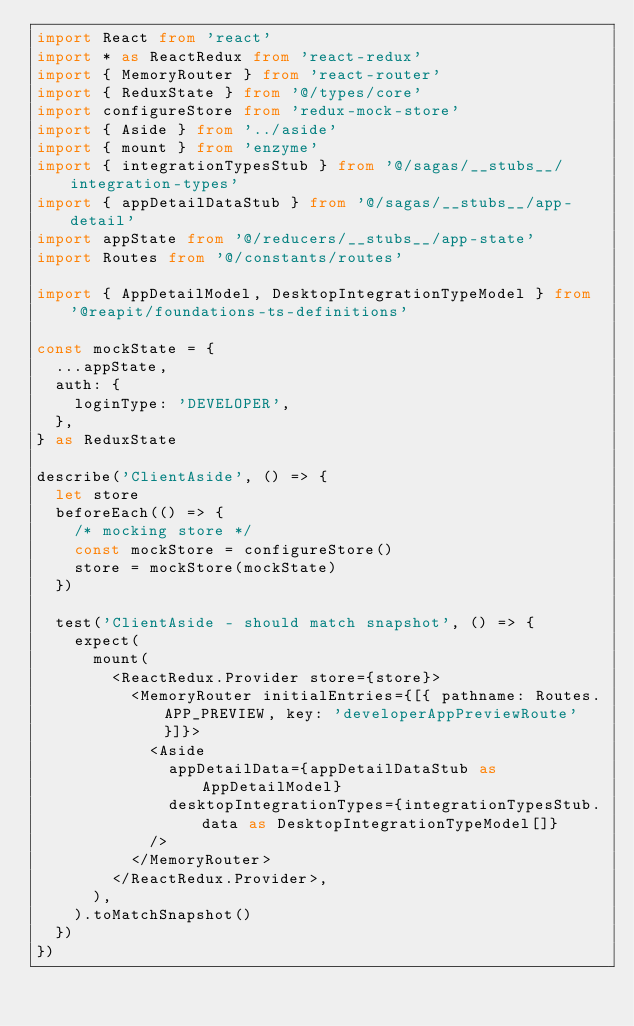<code> <loc_0><loc_0><loc_500><loc_500><_TypeScript_>import React from 'react'
import * as ReactRedux from 'react-redux'
import { MemoryRouter } from 'react-router'
import { ReduxState } from '@/types/core'
import configureStore from 'redux-mock-store'
import { Aside } from '../aside'
import { mount } from 'enzyme'
import { integrationTypesStub } from '@/sagas/__stubs__/integration-types'
import { appDetailDataStub } from '@/sagas/__stubs__/app-detail'
import appState from '@/reducers/__stubs__/app-state'
import Routes from '@/constants/routes'

import { AppDetailModel, DesktopIntegrationTypeModel } from '@reapit/foundations-ts-definitions'

const mockState = {
  ...appState,
  auth: {
    loginType: 'DEVELOPER',
  },
} as ReduxState

describe('ClientAside', () => {
  let store
  beforeEach(() => {
    /* mocking store */
    const mockStore = configureStore()
    store = mockStore(mockState)
  })

  test('ClientAside - should match snapshot', () => {
    expect(
      mount(
        <ReactRedux.Provider store={store}>
          <MemoryRouter initialEntries={[{ pathname: Routes.APP_PREVIEW, key: 'developerAppPreviewRoute' }]}>
            <Aside
              appDetailData={appDetailDataStub as AppDetailModel}
              desktopIntegrationTypes={integrationTypesStub.data as DesktopIntegrationTypeModel[]}
            />
          </MemoryRouter>
        </ReactRedux.Provider>,
      ),
    ).toMatchSnapshot()
  })
})
</code> 